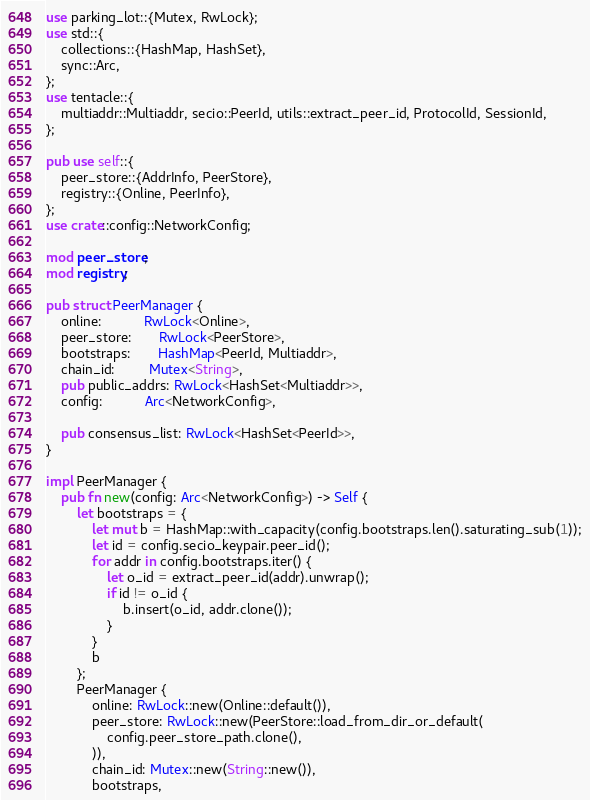<code> <loc_0><loc_0><loc_500><loc_500><_Rust_>use parking_lot::{Mutex, RwLock};
use std::{
    collections::{HashMap, HashSet},
    sync::Arc,
};
use tentacle::{
    multiaddr::Multiaddr, secio::PeerId, utils::extract_peer_id, ProtocolId, SessionId,
};

pub use self::{
    peer_store::{AddrInfo, PeerStore},
    registry::{Online, PeerInfo},
};
use crate::config::NetworkConfig;

mod peer_store;
mod registry;

pub struct PeerManager {
    online:           RwLock<Online>,
    peer_store:       RwLock<PeerStore>,
    bootstraps:       HashMap<PeerId, Multiaddr>,
    chain_id:         Mutex<String>,
    pub public_addrs: RwLock<HashSet<Multiaddr>>,
    config:           Arc<NetworkConfig>,

    pub consensus_list: RwLock<HashSet<PeerId>>,
}

impl PeerManager {
    pub fn new(config: Arc<NetworkConfig>) -> Self {
        let bootstraps = {
            let mut b = HashMap::with_capacity(config.bootstraps.len().saturating_sub(1));
            let id = config.secio_keypair.peer_id();
            for addr in config.bootstraps.iter() {
                let o_id = extract_peer_id(addr).unwrap();
                if id != o_id {
                    b.insert(o_id, addr.clone());
                }
            }
            b
        };
        PeerManager {
            online: RwLock::new(Online::default()),
            peer_store: RwLock::new(PeerStore::load_from_dir_or_default(
                config.peer_store_path.clone(),
            )),
            chain_id: Mutex::new(String::new()),
            bootstraps,</code> 